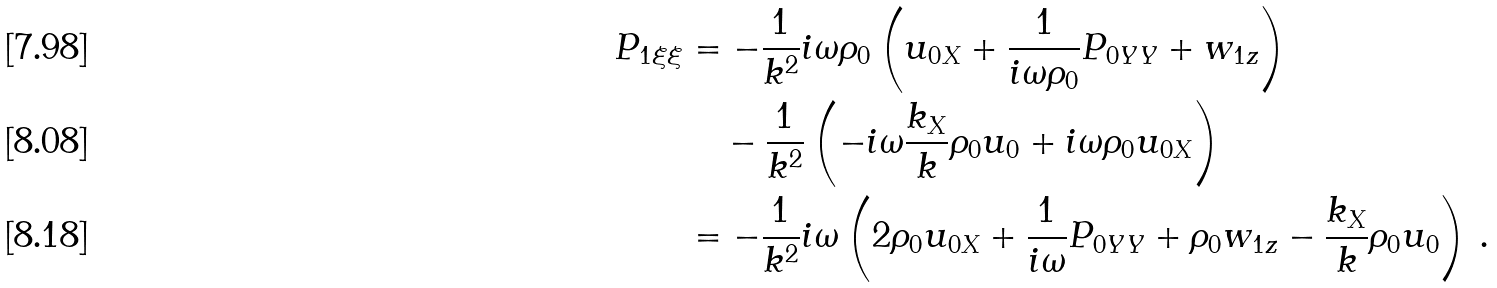Convert formula to latex. <formula><loc_0><loc_0><loc_500><loc_500>P _ { 1 \xi \xi } & = - \frac { 1 } { k ^ { 2 } } i \omega \rho _ { 0 } \left ( u _ { 0 X } + \frac { 1 } { i \omega \rho _ { 0 } } P _ { 0 Y Y } + w _ { 1 z } \right ) \\ & \quad - \frac { 1 } { k ^ { 2 } } \left ( - i \omega \frac { k _ { X } } { k } \rho _ { 0 } u _ { 0 } + i \omega \rho _ { 0 } u _ { 0 X } \right ) \\ & = - \frac { 1 } { k ^ { 2 } } i \omega \left ( 2 \rho _ { 0 } u _ { 0 X } + \frac { 1 } { i \omega } P _ { 0 Y Y } + \rho _ { 0 } w _ { 1 z } - \frac { k _ { X } } { k } \rho _ { 0 } u _ { 0 } \right ) \, .</formula> 